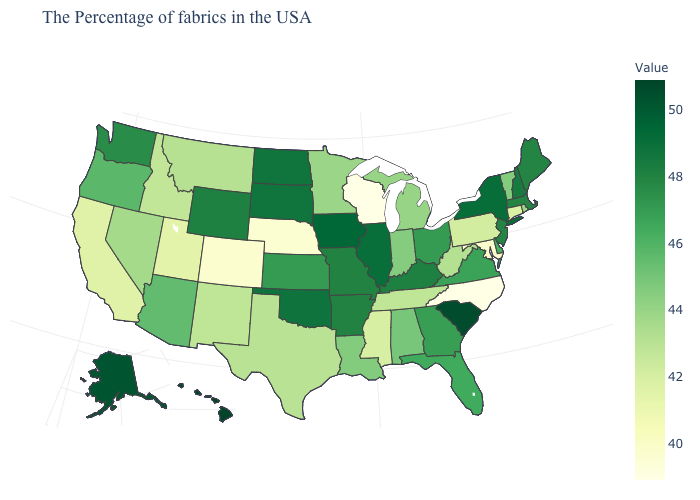Does North Dakota have a lower value than Hawaii?
Quick response, please. Yes. Which states have the highest value in the USA?
Short answer required. Hawaii. Which states have the lowest value in the USA?
Be succinct. North Carolina, Wisconsin. Is the legend a continuous bar?
Short answer required. Yes. Does Mississippi have a higher value than Nebraska?
Concise answer only. Yes. Which states hav the highest value in the MidWest?
Write a very short answer. Iowa. Which states have the lowest value in the USA?
Write a very short answer. North Carolina, Wisconsin. 